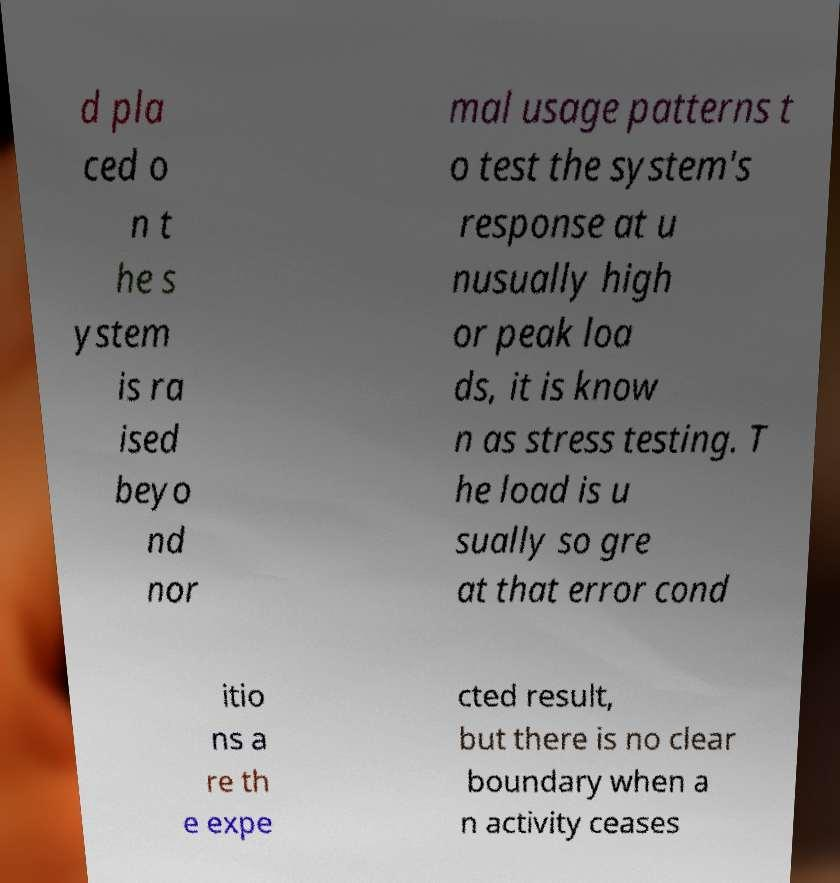What messages or text are displayed in this image? I need them in a readable, typed format. d pla ced o n t he s ystem is ra ised beyo nd nor mal usage patterns t o test the system's response at u nusually high or peak loa ds, it is know n as stress testing. T he load is u sually so gre at that error cond itio ns a re th e expe cted result, but there is no clear boundary when a n activity ceases 